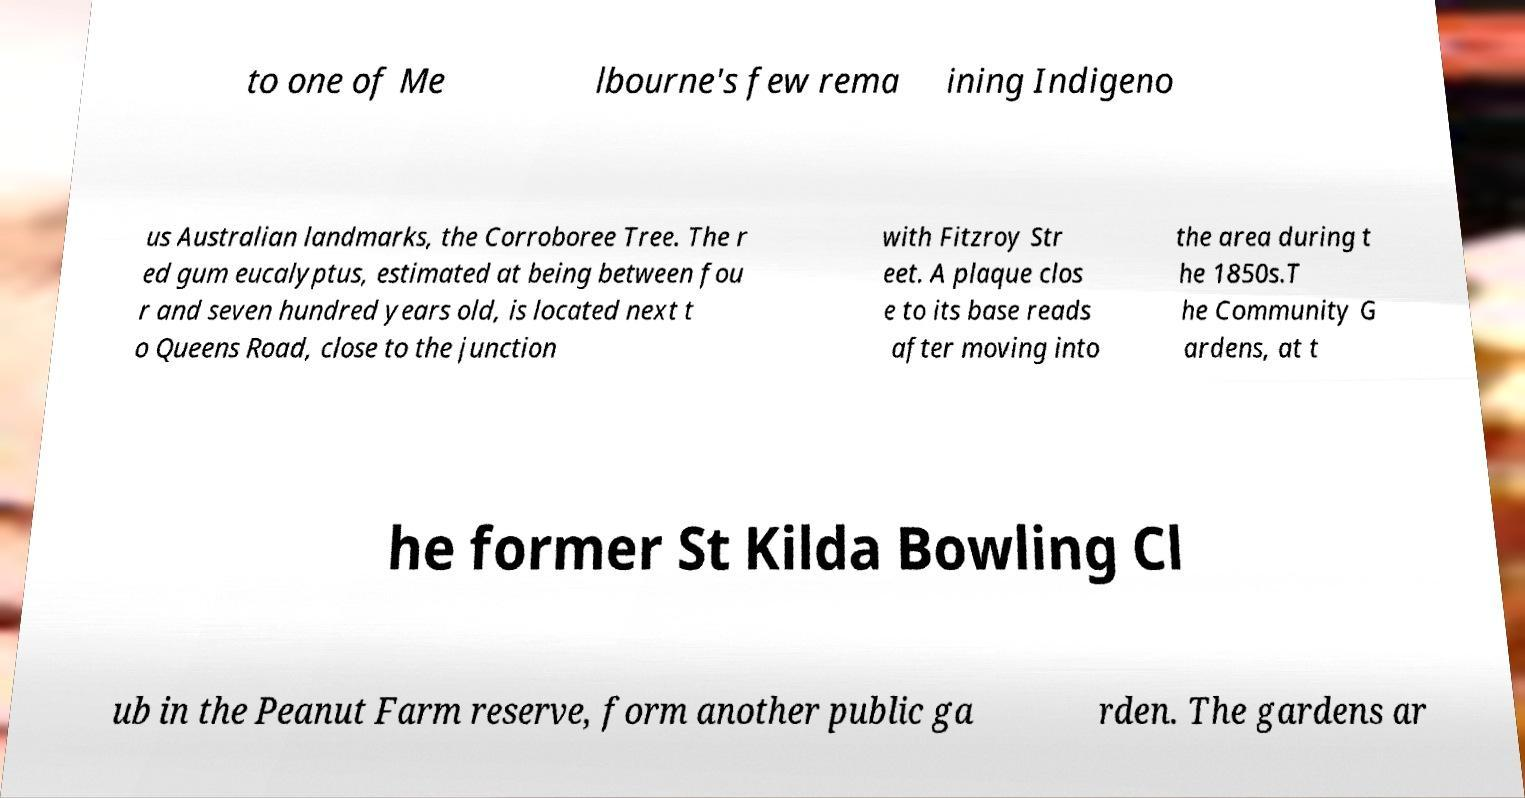Please read and relay the text visible in this image. What does it say? to one of Me lbourne's few rema ining Indigeno us Australian landmarks, the Corroboree Tree. The r ed gum eucalyptus, estimated at being between fou r and seven hundred years old, is located next t o Queens Road, close to the junction with Fitzroy Str eet. A plaque clos e to its base reads after moving into the area during t he 1850s.T he Community G ardens, at t he former St Kilda Bowling Cl ub in the Peanut Farm reserve, form another public ga rden. The gardens ar 